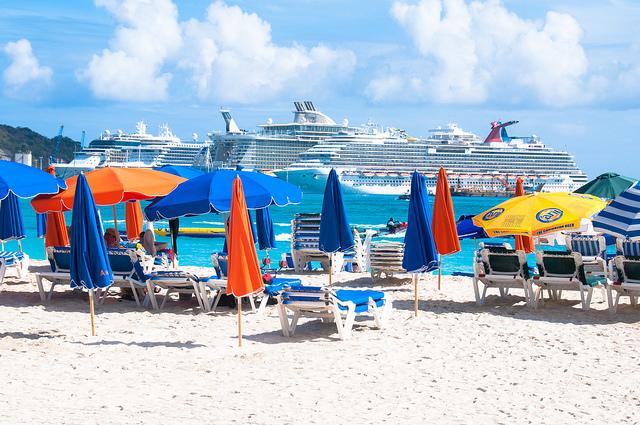How many cruise ships are there?
Be succinct. 2. Are there any deck chairs on the beach?
Keep it brief. Yes. How many open umbrellas are there on the beach?
Short answer required. 7. 